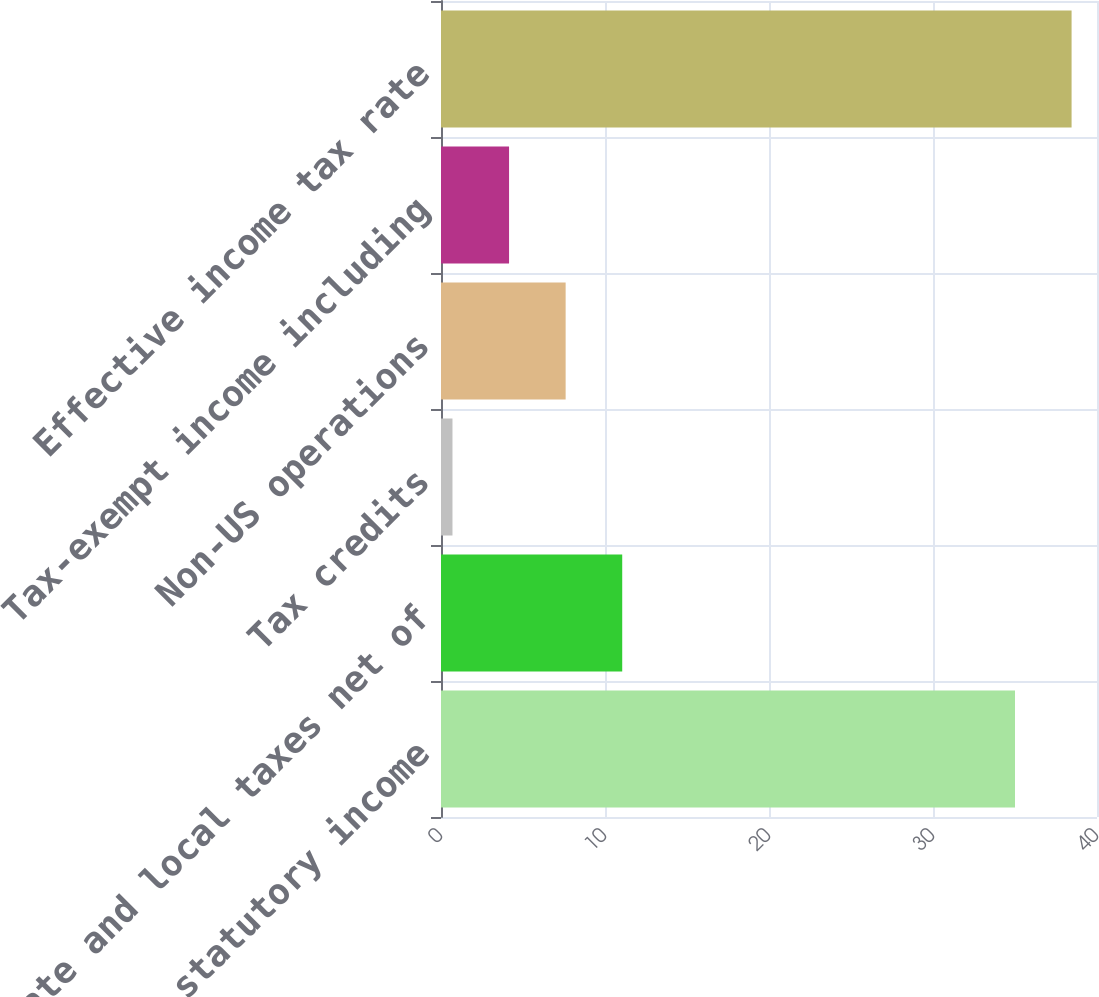<chart> <loc_0><loc_0><loc_500><loc_500><bar_chart><fcel>US federal statutory income<fcel>State and local taxes net of<fcel>Tax credits<fcel>Non-US operations<fcel>Tax-exempt income including<fcel>Effective income tax rate<nl><fcel>35<fcel>11.05<fcel>0.7<fcel>7.6<fcel>4.15<fcel>38.45<nl></chart> 